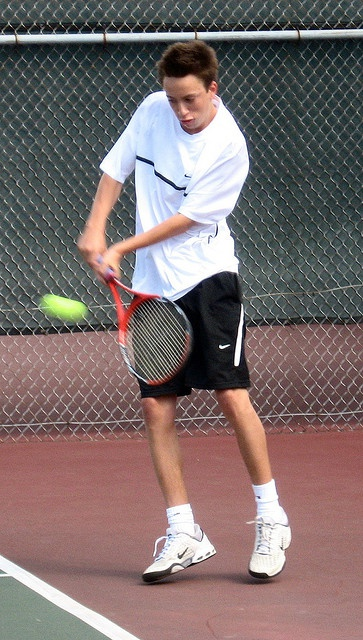Describe the objects in this image and their specific colors. I can see people in gray, lavender, black, and salmon tones, tennis racket in gray, black, darkgray, and maroon tones, and sports ball in gray, khaki, and lightgreen tones in this image. 